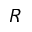Convert formula to latex. <formula><loc_0><loc_0><loc_500><loc_500>R</formula> 